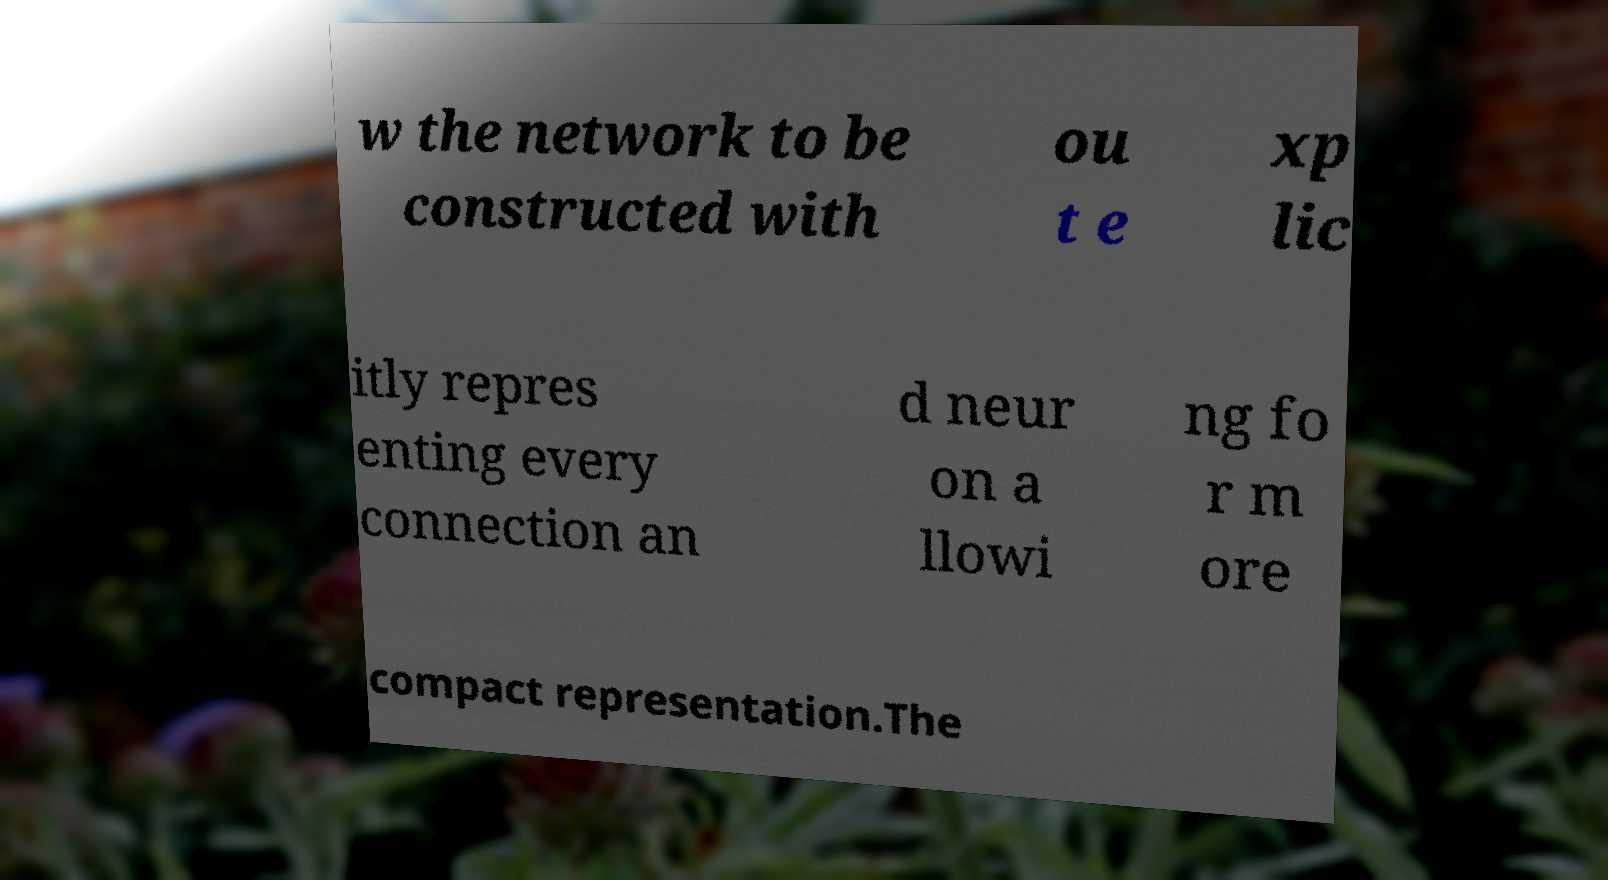Could you extract and type out the text from this image? w the network to be constructed with ou t e xp lic itly repres enting every connection an d neur on a llowi ng fo r m ore compact representation.The 